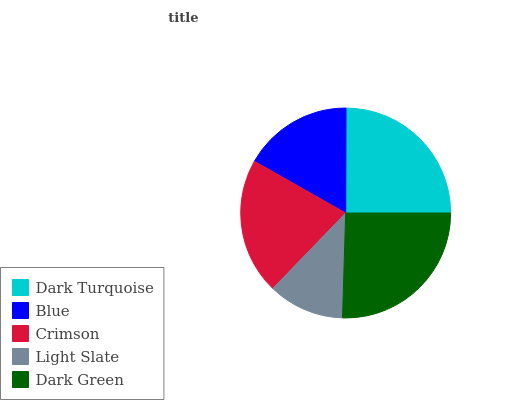Is Light Slate the minimum?
Answer yes or no. Yes. Is Dark Green the maximum?
Answer yes or no. Yes. Is Blue the minimum?
Answer yes or no. No. Is Blue the maximum?
Answer yes or no. No. Is Dark Turquoise greater than Blue?
Answer yes or no. Yes. Is Blue less than Dark Turquoise?
Answer yes or no. Yes. Is Blue greater than Dark Turquoise?
Answer yes or no. No. Is Dark Turquoise less than Blue?
Answer yes or no. No. Is Crimson the high median?
Answer yes or no. Yes. Is Crimson the low median?
Answer yes or no. Yes. Is Light Slate the high median?
Answer yes or no. No. Is Light Slate the low median?
Answer yes or no. No. 